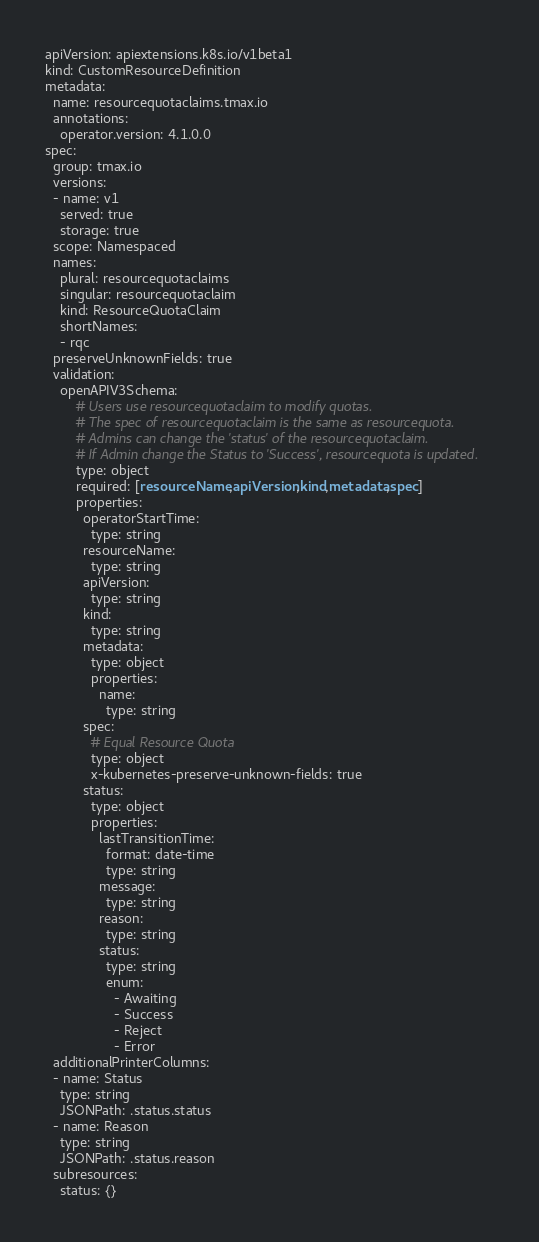Convert code to text. <code><loc_0><loc_0><loc_500><loc_500><_YAML_>apiVersion: apiextensions.k8s.io/v1beta1
kind: CustomResourceDefinition
metadata:
  name: resourcequotaclaims.tmax.io
  annotations:
    operator.version: 4.1.0.0
spec:
  group: tmax.io
  versions:
  - name: v1
    served: true
    storage: true
  scope: Namespaced
  names:
    plural: resourcequotaclaims
    singular: resourcequotaclaim
    kind: ResourceQuotaClaim
    shortNames:
    - rqc
  preserveUnknownFields: true
  validation:
    openAPIV3Schema:
        # Users use resourcequotaclaim to modify quotas.
        # The spec of resourcequotaclaim is the same as resourcequota.
        # Admins can change the 'status' of the resourcequotaclaim.
        # If Admin change the Status to 'Success', resourcequota is updated.
        type: object
        required: [resourceName,apiVersion,kind,metadata,spec]
        properties:
          operatorStartTime:
            type: string
          resourceName:
            type: string
          apiVersion:
            type: string
          kind:
            type: string
          metadata:
            type: object
            properties:
              name:
                type: string
          spec:
            # Equal Resource Quota
            type: object
            x-kubernetes-preserve-unknown-fields: true
          status:
            type: object
            properties:
              lastTransitionTime:
                format: date-time
                type: string
              message:
                type: string
              reason:
                type: string
              status:
                type: string
                enum:
                  - Awaiting
                  - Success
                  - Reject
                  - Error
  additionalPrinterColumns:
  - name: Status
    type: string
    JSONPath: .status.status
  - name: Reason
    type: string
    JSONPath: .status.reason
  subresources:
    status: {}</code> 